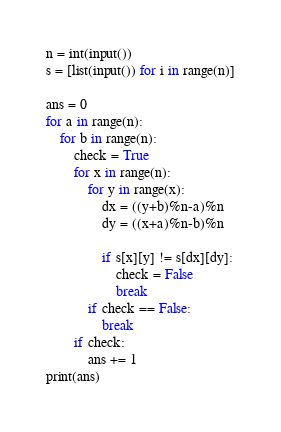<code> <loc_0><loc_0><loc_500><loc_500><_Python_>n = int(input())
s = [list(input()) for i in range(n)]

ans = 0
for a in range(n):
    for b in range(n):
        check = True
        for x in range(n):
            for y in range(x):
                dx = ((y+b)%n-a)%n
                dy = ((x+a)%n-b)%n
                
                if s[x][y] != s[dx][dy]:
                    check = False
                    break
            if check == False:
                break
        if check:
            ans += 1
print(ans)</code> 